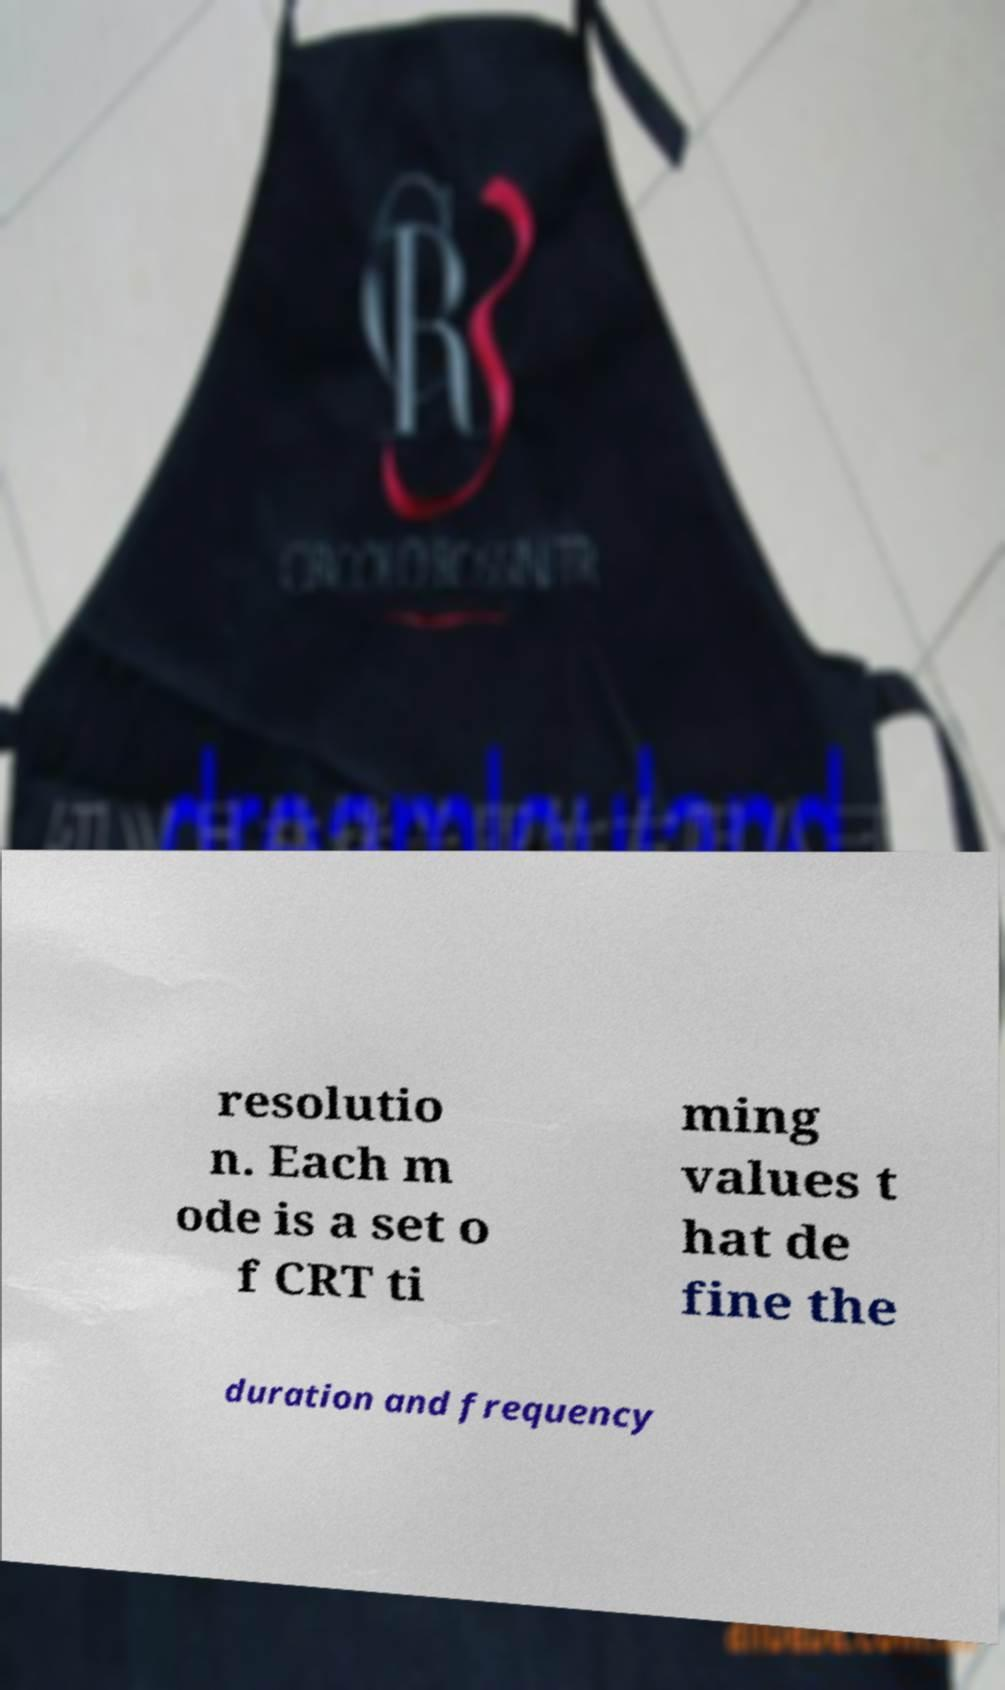Could you assist in decoding the text presented in this image and type it out clearly? resolutio n. Each m ode is a set o f CRT ti ming values t hat de fine the duration and frequency 